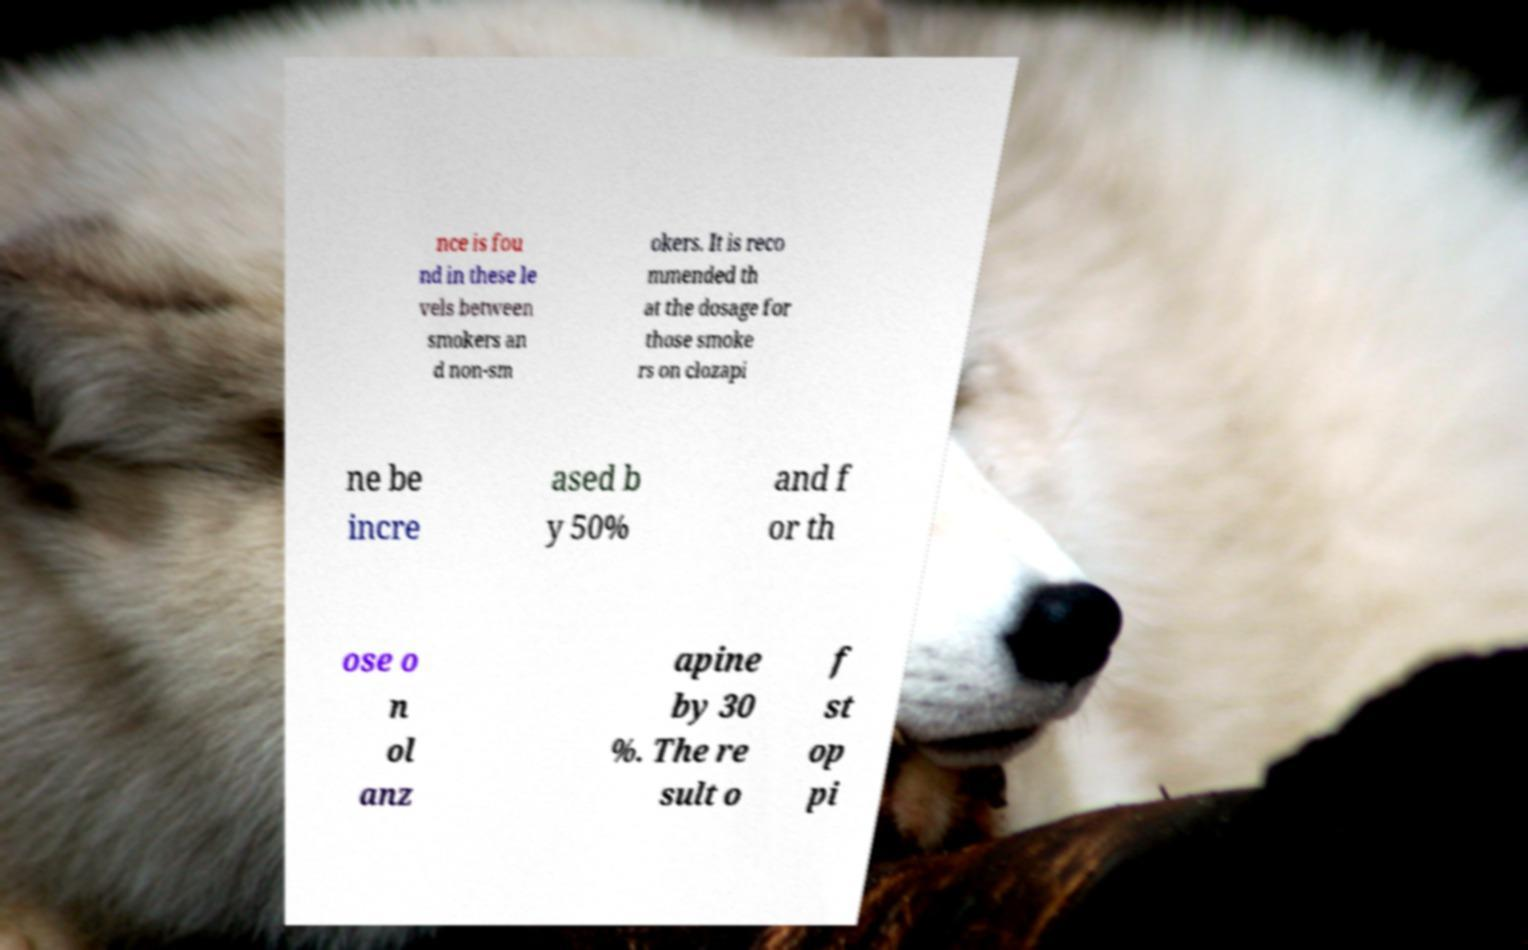There's text embedded in this image that I need extracted. Can you transcribe it verbatim? nce is fou nd in these le vels between smokers an d non-sm okers. It is reco mmended th at the dosage for those smoke rs on clozapi ne be incre ased b y 50% and f or th ose o n ol anz apine by 30 %. The re sult o f st op pi 